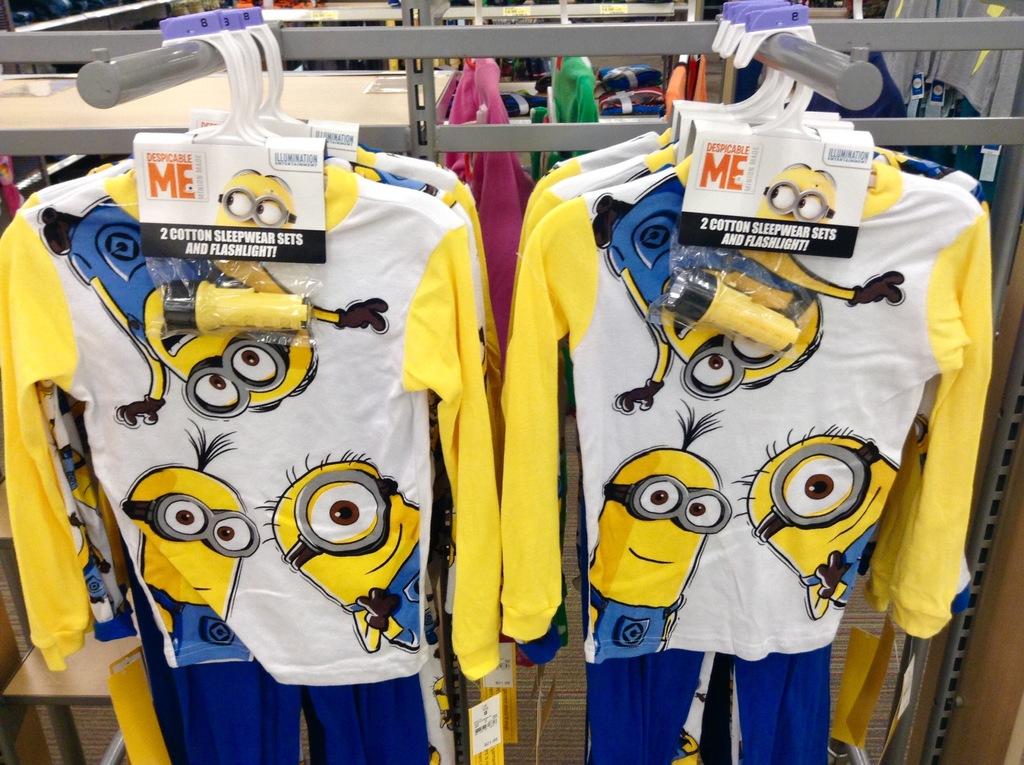How many sleepwear sets come with the flashlight?
Offer a terse response. 2. What movie is this from?
Ensure brevity in your answer.  Despicable me. 